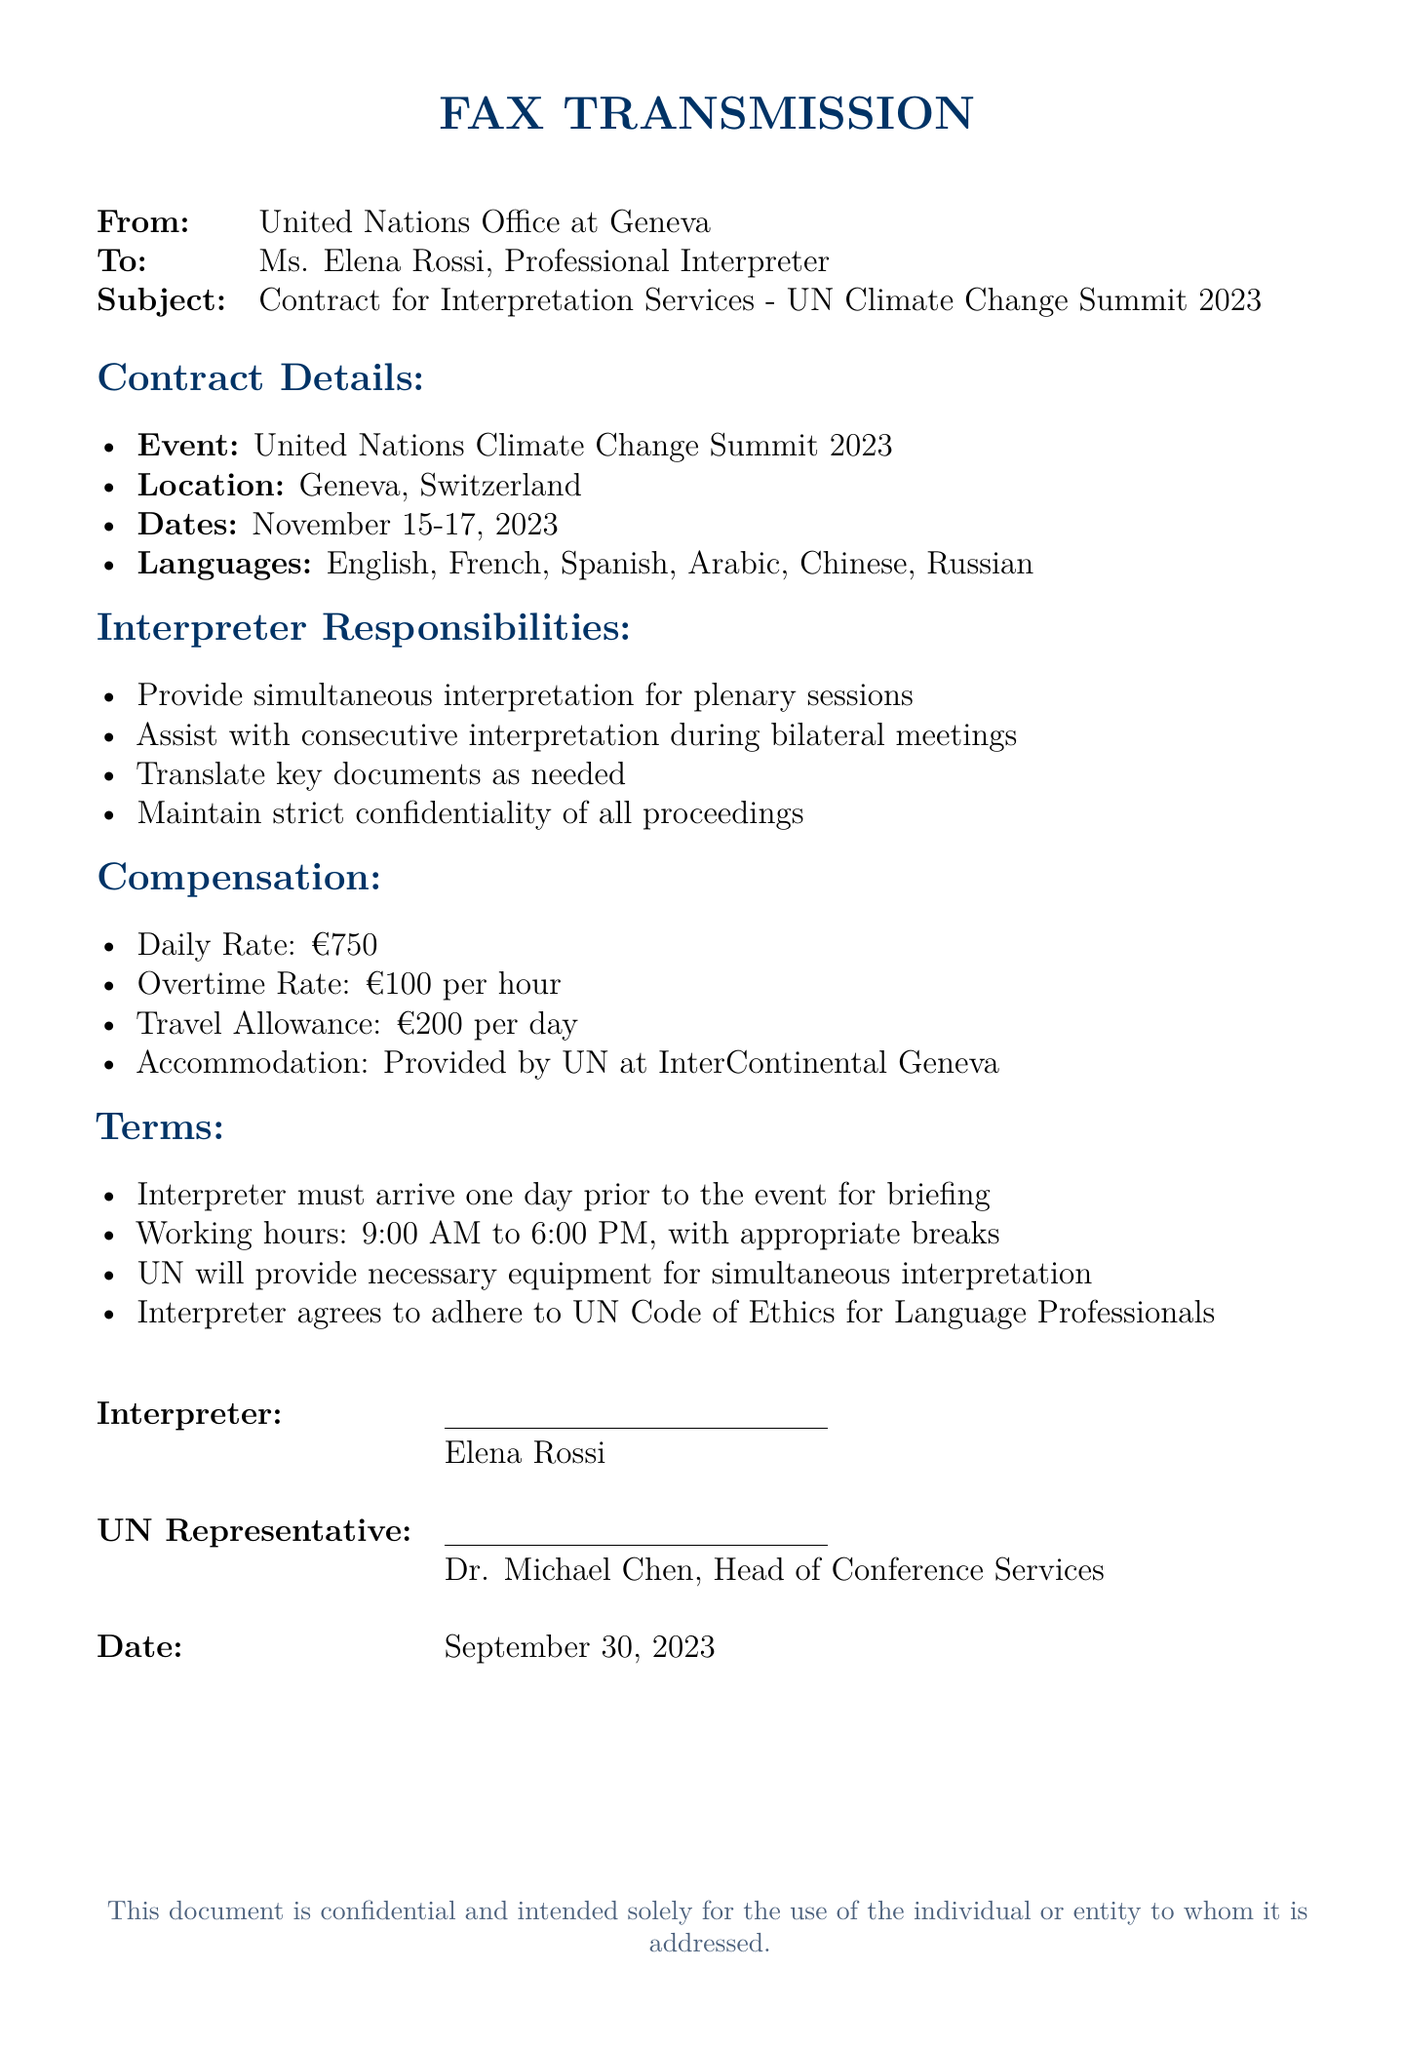What is the event? The event mentioned in the document is the "United Nations Climate Change Summit 2023."
Answer: United Nations Climate Change Summit 2023 What are the dates of the event? The specific dates for the event are listed as November 15-17, 2023.
Answer: November 15-17, 2023 What is the daily rate for the interpreter? The document specifies that the daily rate for the interpreter is €750.
Answer: €750 Who is the UN representative? The name of the UN representative mentioned in the document is Dr. Michael Chen.
Answer: Dr. Michael Chen What is the maximum overtime rate per hour? The document indicates that the overtime rate is €100 per hour.
Answer: €100 How many languages will be interpreted at the summit? The document lists a total of six languages to be interpreted during the summit.
Answer: Six What is one of the interpreter's responsibilities? The responsibilities outlined for the interpreter include providing simultaneous interpretation for plenary sessions.
Answer: Provide simultaneous interpretation for plenary sessions What day should the interpreter arrive prior to the event? The contract specifies that the interpreter must arrive one day prior to the event for briefing.
Answer: One day prior What accommodation is provided for the interpreter? The document states that accommodation will be provided by UN at InterContinental Geneva.
Answer: InterContinental Geneva 